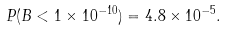Convert formula to latex. <formula><loc_0><loc_0><loc_500><loc_500>P ( B < 1 \times 1 0 ^ { - 1 0 } ) = 4 . 8 \times 1 0 ^ { - 5 } .</formula> 